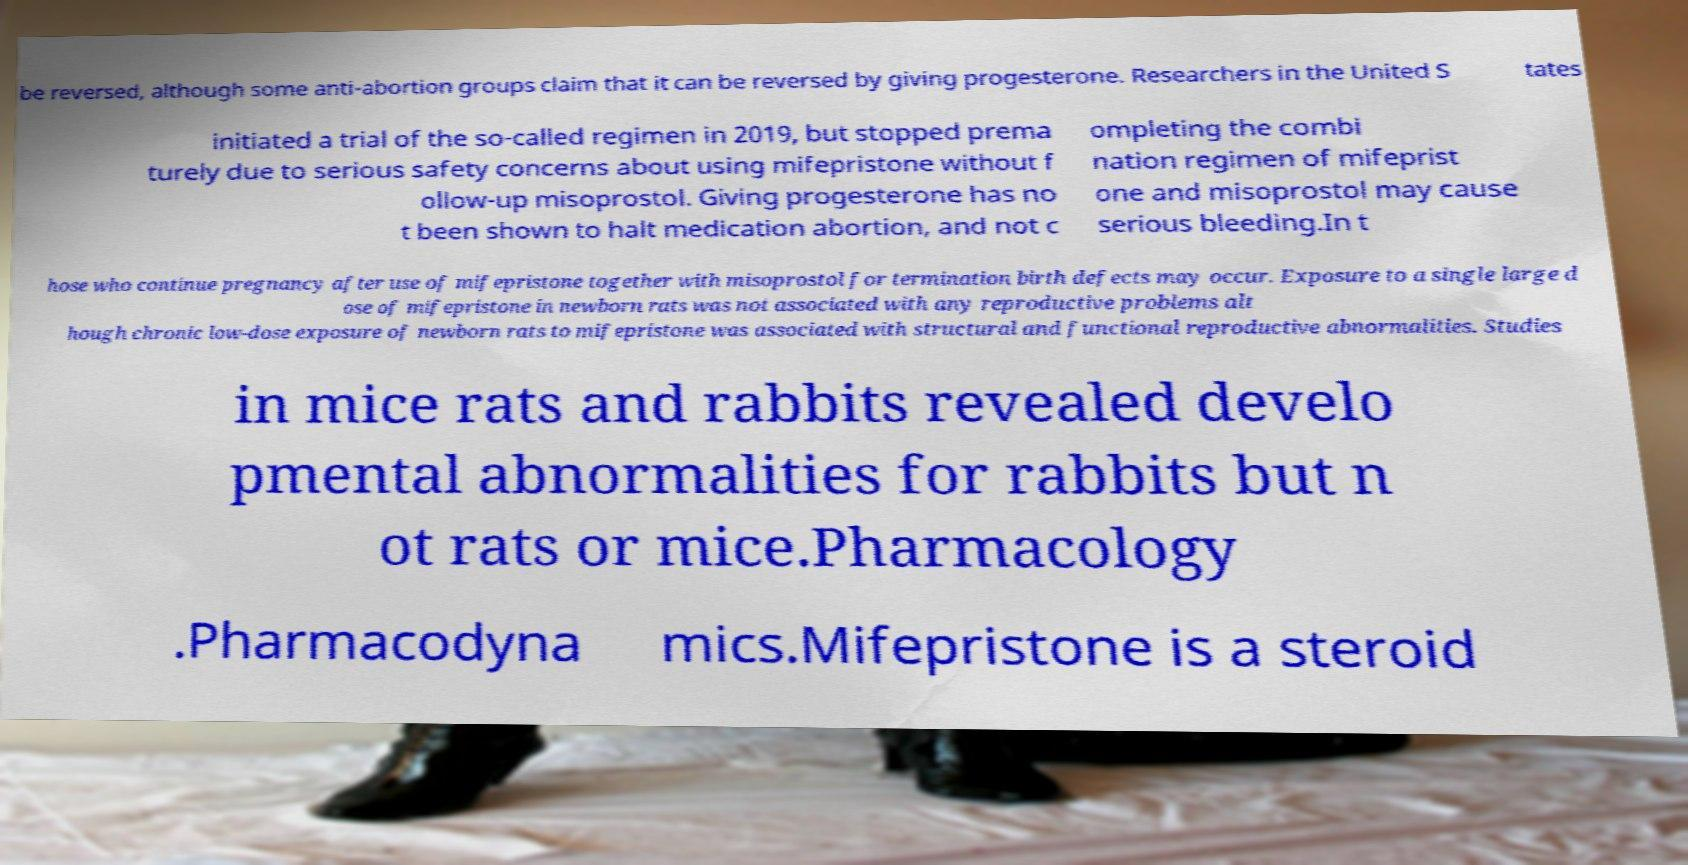Could you extract and type out the text from this image? be reversed, although some anti-abortion groups claim that it can be reversed by giving progesterone. Researchers in the United S tates initiated a trial of the so-called regimen in 2019, but stopped prema turely due to serious safety concerns about using mifepristone without f ollow-up misoprostol. Giving progesterone has no t been shown to halt medication abortion, and not c ompleting the combi nation regimen of mifeprist one and misoprostol may cause serious bleeding.In t hose who continue pregnancy after use of mifepristone together with misoprostol for termination birth defects may occur. Exposure to a single large d ose of mifepristone in newborn rats was not associated with any reproductive problems alt hough chronic low-dose exposure of newborn rats to mifepristone was associated with structural and functional reproductive abnormalities. Studies in mice rats and rabbits revealed develo pmental abnormalities for rabbits but n ot rats or mice.Pharmacology .Pharmacodyna mics.Mifepristone is a steroid 